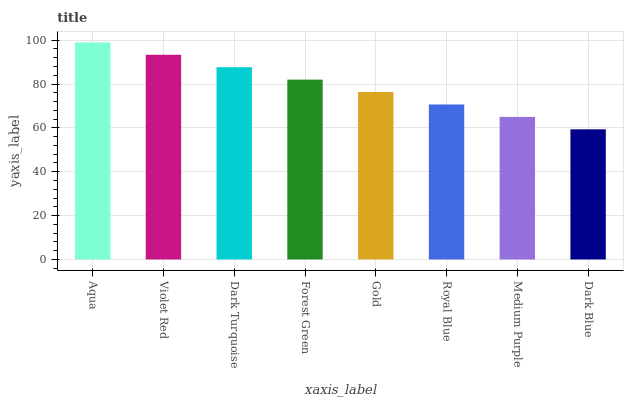Is Dark Blue the minimum?
Answer yes or no. Yes. Is Aqua the maximum?
Answer yes or no. Yes. Is Violet Red the minimum?
Answer yes or no. No. Is Violet Red the maximum?
Answer yes or no. No. Is Aqua greater than Violet Red?
Answer yes or no. Yes. Is Violet Red less than Aqua?
Answer yes or no. Yes. Is Violet Red greater than Aqua?
Answer yes or no. No. Is Aqua less than Violet Red?
Answer yes or no. No. Is Forest Green the high median?
Answer yes or no. Yes. Is Gold the low median?
Answer yes or no. Yes. Is Medium Purple the high median?
Answer yes or no. No. Is Royal Blue the low median?
Answer yes or no. No. 